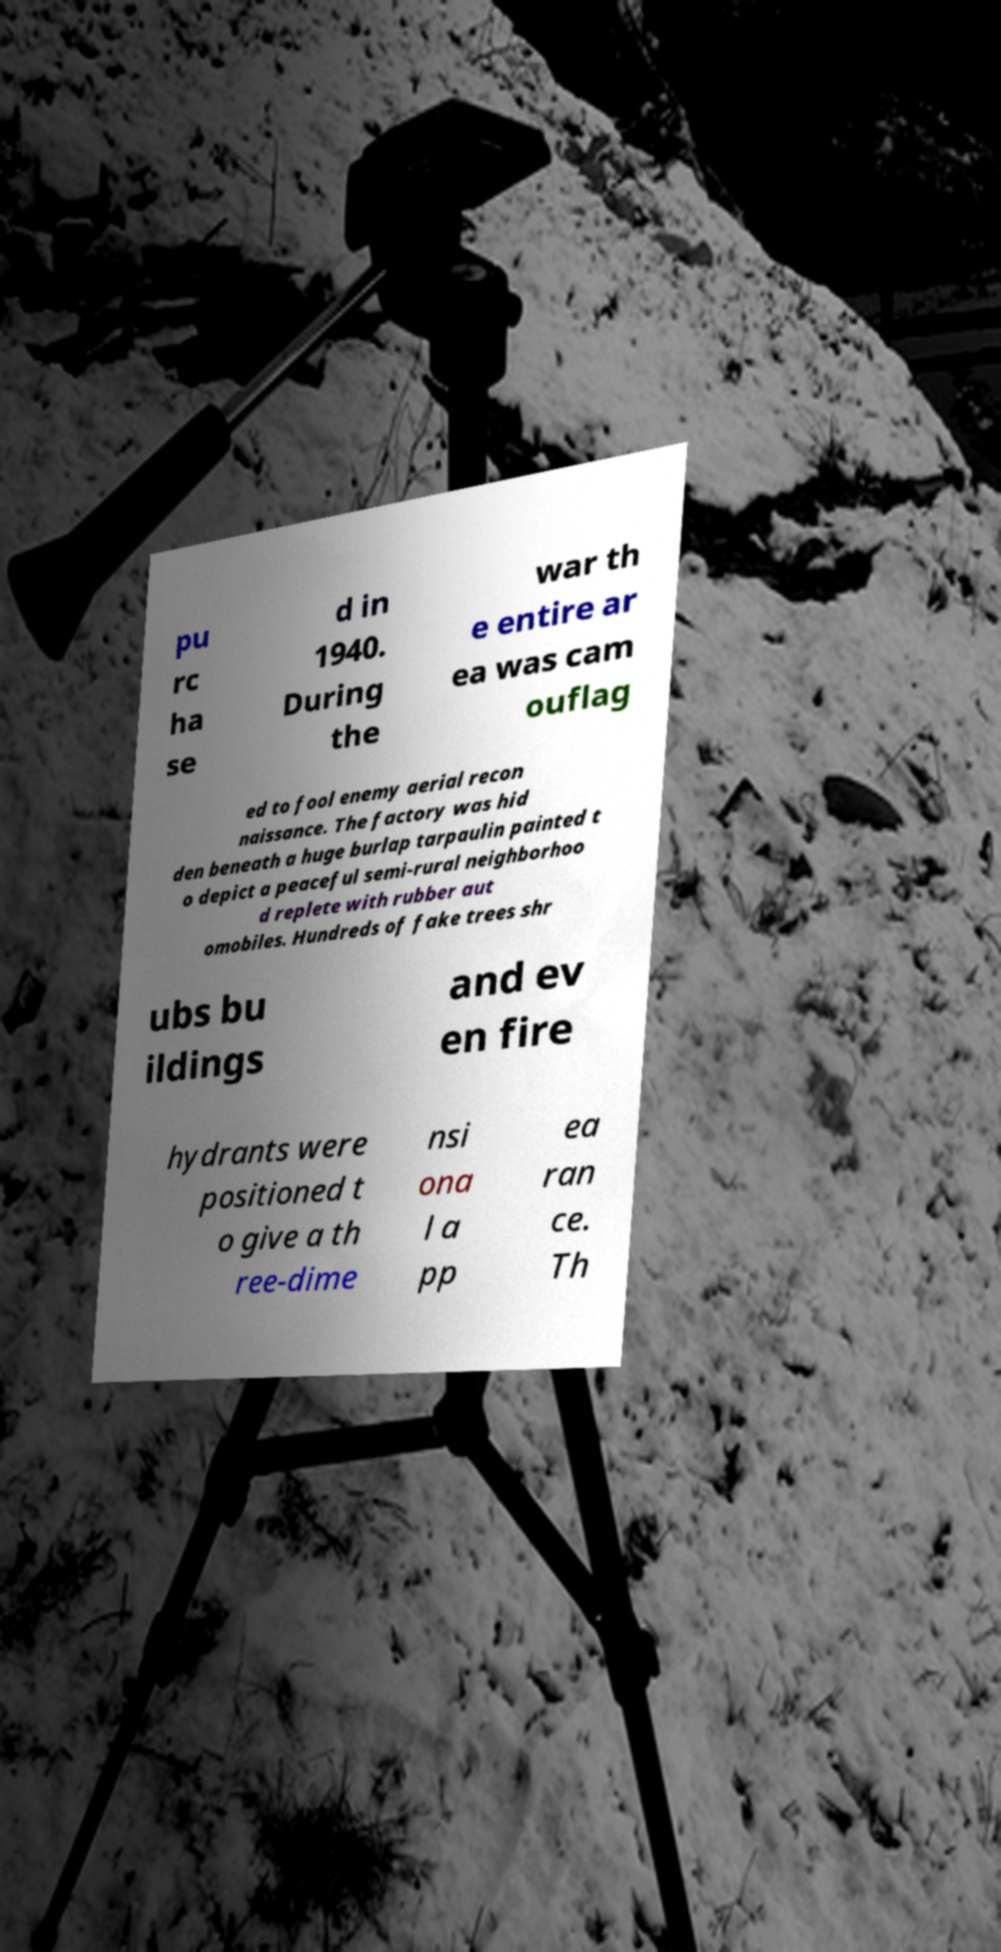Please identify and transcribe the text found in this image. pu rc ha se d in 1940. During the war th e entire ar ea was cam ouflag ed to fool enemy aerial recon naissance. The factory was hid den beneath a huge burlap tarpaulin painted t o depict a peaceful semi-rural neighborhoo d replete with rubber aut omobiles. Hundreds of fake trees shr ubs bu ildings and ev en fire hydrants were positioned t o give a th ree-dime nsi ona l a pp ea ran ce. Th 